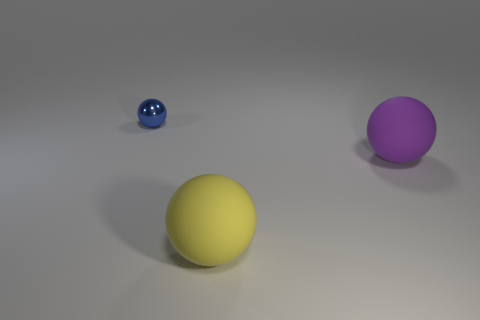Is there anything else that has the same size as the blue object?
Ensure brevity in your answer.  No. How many things are rubber spheres behind the yellow sphere or objects that are right of the metallic object?
Make the answer very short. 2. Is the number of large matte spheres less than the number of spheres?
Your response must be concise. Yes. What shape is the purple thing that is the same size as the yellow rubber object?
Ensure brevity in your answer.  Sphere. What number of small blue things are there?
Offer a terse response. 1. What number of spheres are both in front of the tiny blue shiny object and to the left of the large purple sphere?
Offer a terse response. 1. What is the material of the tiny blue object?
Your answer should be very brief. Metal. Are there any purple metal things?
Your answer should be compact. No. There is a big object to the left of the purple rubber ball; what is its color?
Give a very brief answer. Yellow. What number of matte spheres are behind the big ball that is left of the rubber ball behind the yellow thing?
Make the answer very short. 1. 